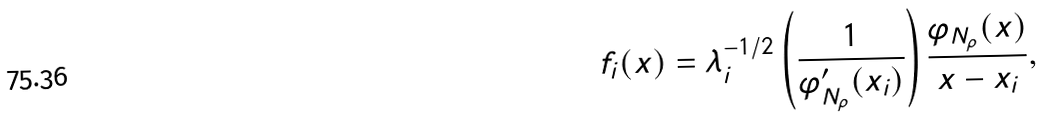Convert formula to latex. <formula><loc_0><loc_0><loc_500><loc_500>f _ { i } ( x ) = \lambda _ { i } ^ { - 1 / 2 } \left ( \frac { 1 } { { \varphi ^ { \prime } _ { N _ { \rho } } } ( x _ { i } ) } \right ) \frac { { \varphi _ { N _ { \rho } } } ( x ) } { x - x _ { i } } ,</formula> 